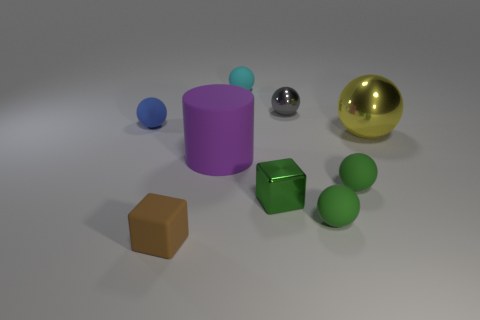Subtract all big shiny balls. How many balls are left? 5 Add 1 small blue objects. How many objects exist? 10 Subtract all brown cubes. How many green spheres are left? 2 Subtract all blue balls. How many balls are left? 5 Add 9 small gray objects. How many small gray objects exist? 10 Subtract 0 cyan blocks. How many objects are left? 9 Subtract all balls. How many objects are left? 3 Subtract 1 cubes. How many cubes are left? 1 Subtract all green cylinders. Subtract all purple balls. How many cylinders are left? 1 Subtract all metallic objects. Subtract all gray matte spheres. How many objects are left? 6 